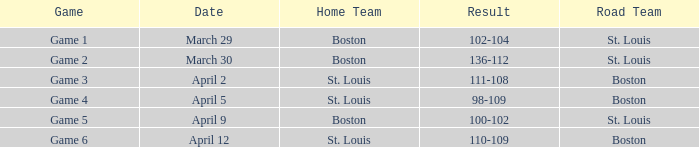What is the contest number on april 12 involving st. louis home team? Game 6. 